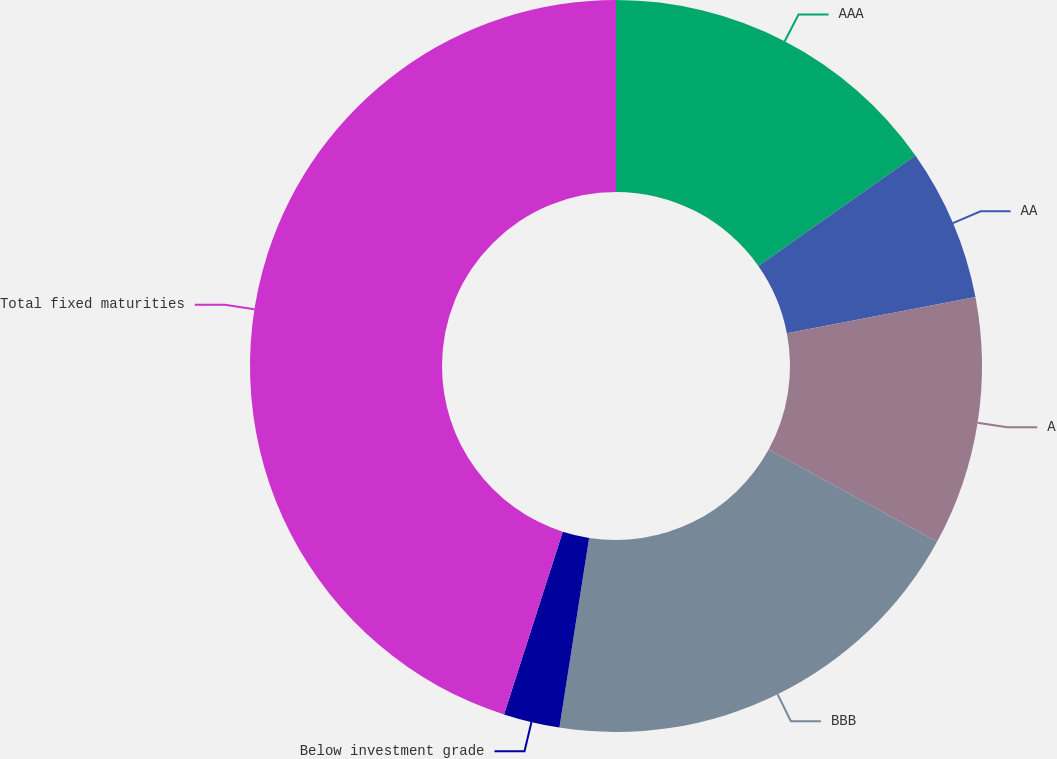Convert chart. <chart><loc_0><loc_0><loc_500><loc_500><pie_chart><fcel>AAA<fcel>AA<fcel>A<fcel>BBB<fcel>Below investment grade<fcel>Total fixed maturities<nl><fcel>15.25%<fcel>6.73%<fcel>10.99%<fcel>19.5%<fcel>2.48%<fcel>45.05%<nl></chart> 